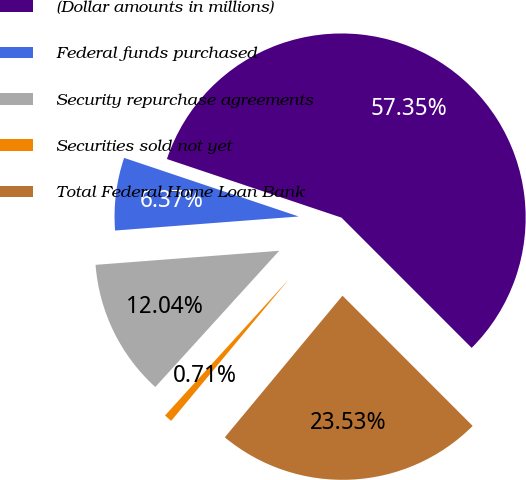Convert chart to OTSL. <chart><loc_0><loc_0><loc_500><loc_500><pie_chart><fcel>(Dollar amounts in millions)<fcel>Federal funds purchased<fcel>Security repurchase agreements<fcel>Securities sold not yet<fcel>Total Federal Home Loan Bank<nl><fcel>57.35%<fcel>6.37%<fcel>12.04%<fcel>0.71%<fcel>23.53%<nl></chart> 